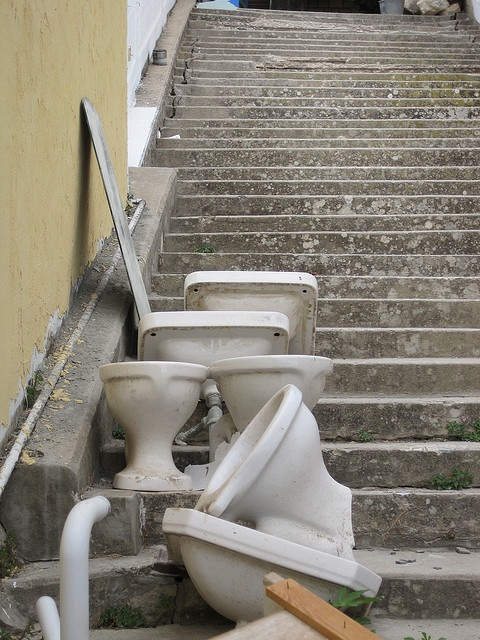Describe the objects in this image and their specific colors. I can see toilet in tan, darkgray, lightgray, and gray tones, sink in tan, gray, darkgray, lightgray, and darkgreen tones, toilet in tan, darkgray, gray, and lightgray tones, sink in tan, darkgray, lightgray, and gray tones, and sink in tan, darkgray, lightgray, and gray tones in this image. 